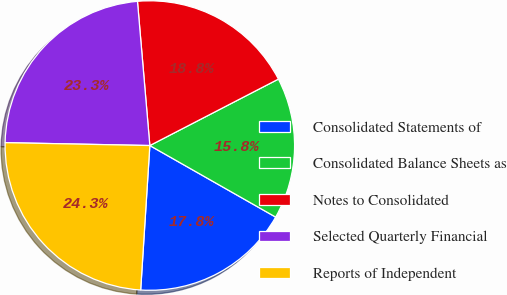Convert chart to OTSL. <chart><loc_0><loc_0><loc_500><loc_500><pie_chart><fcel>Consolidated Statements of<fcel>Consolidated Balance Sheets as<fcel>Notes to Consolidated<fcel>Selected Quarterly Financial<fcel>Reports of Independent<nl><fcel>17.78%<fcel>15.82%<fcel>18.77%<fcel>23.32%<fcel>24.31%<nl></chart> 